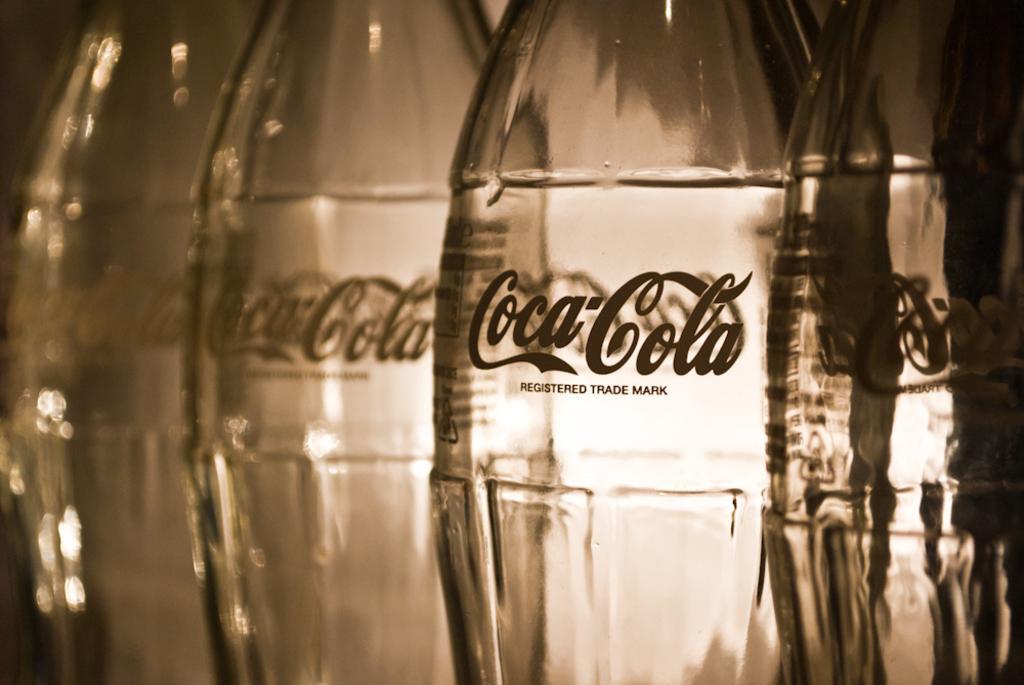Please provide a concise description of this image. This picture is mainly highlighted with bottles. 